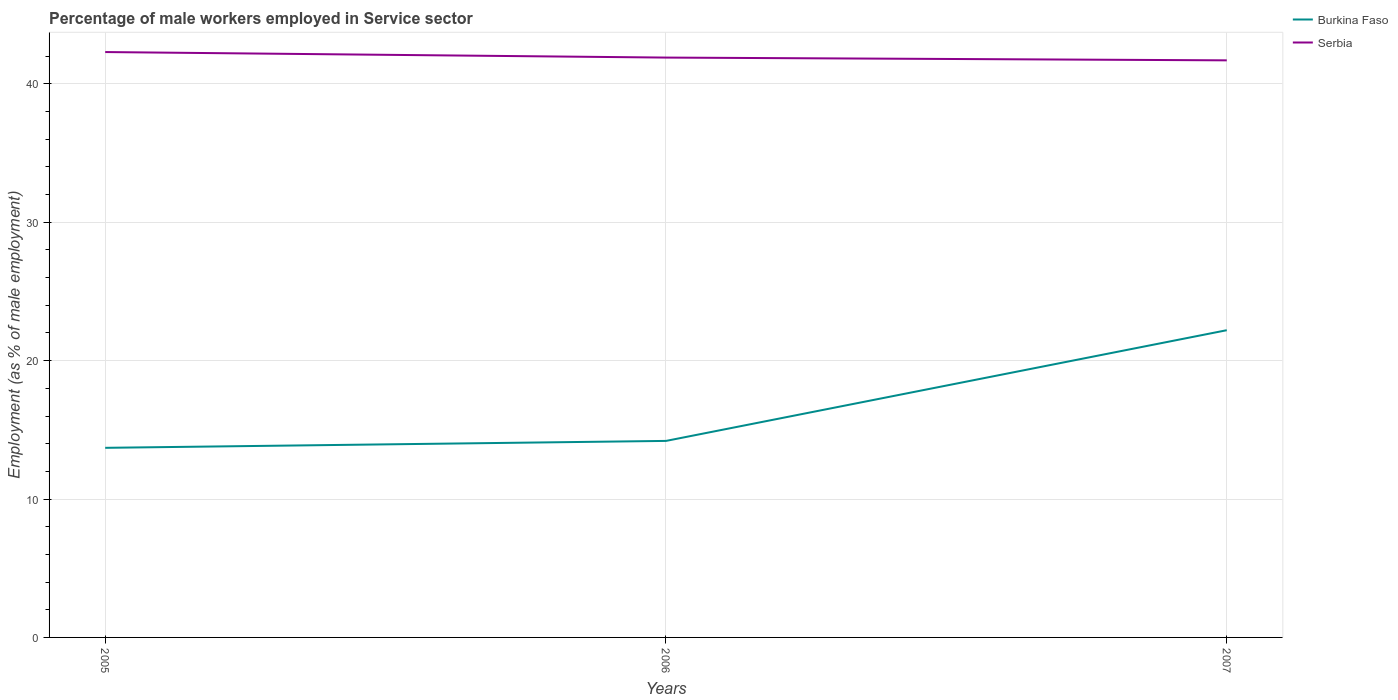Does the line corresponding to Serbia intersect with the line corresponding to Burkina Faso?
Your response must be concise. No. Across all years, what is the maximum percentage of male workers employed in Service sector in Serbia?
Provide a short and direct response. 41.7. What is the total percentage of male workers employed in Service sector in Serbia in the graph?
Keep it short and to the point. 0.4. What is the difference between the highest and the second highest percentage of male workers employed in Service sector in Serbia?
Provide a succinct answer. 0.6. What is the difference between the highest and the lowest percentage of male workers employed in Service sector in Serbia?
Give a very brief answer. 1. Is the percentage of male workers employed in Service sector in Serbia strictly greater than the percentage of male workers employed in Service sector in Burkina Faso over the years?
Your response must be concise. No. What is the difference between two consecutive major ticks on the Y-axis?
Give a very brief answer. 10. Are the values on the major ticks of Y-axis written in scientific E-notation?
Give a very brief answer. No. Does the graph contain any zero values?
Provide a succinct answer. No. How many legend labels are there?
Give a very brief answer. 2. What is the title of the graph?
Make the answer very short. Percentage of male workers employed in Service sector. Does "Small states" appear as one of the legend labels in the graph?
Make the answer very short. No. What is the label or title of the X-axis?
Your response must be concise. Years. What is the label or title of the Y-axis?
Provide a succinct answer. Employment (as % of male employment). What is the Employment (as % of male employment) of Burkina Faso in 2005?
Keep it short and to the point. 13.7. What is the Employment (as % of male employment) of Serbia in 2005?
Ensure brevity in your answer.  42.3. What is the Employment (as % of male employment) in Burkina Faso in 2006?
Make the answer very short. 14.2. What is the Employment (as % of male employment) of Serbia in 2006?
Offer a very short reply. 41.9. What is the Employment (as % of male employment) in Burkina Faso in 2007?
Make the answer very short. 22.2. What is the Employment (as % of male employment) of Serbia in 2007?
Give a very brief answer. 41.7. Across all years, what is the maximum Employment (as % of male employment) of Burkina Faso?
Your response must be concise. 22.2. Across all years, what is the maximum Employment (as % of male employment) of Serbia?
Your answer should be very brief. 42.3. Across all years, what is the minimum Employment (as % of male employment) of Burkina Faso?
Your response must be concise. 13.7. Across all years, what is the minimum Employment (as % of male employment) of Serbia?
Offer a very short reply. 41.7. What is the total Employment (as % of male employment) of Burkina Faso in the graph?
Keep it short and to the point. 50.1. What is the total Employment (as % of male employment) in Serbia in the graph?
Ensure brevity in your answer.  125.9. What is the difference between the Employment (as % of male employment) of Serbia in 2005 and that in 2006?
Your answer should be compact. 0.4. What is the difference between the Employment (as % of male employment) of Burkina Faso in 2005 and that in 2007?
Ensure brevity in your answer.  -8.5. What is the difference between the Employment (as % of male employment) of Burkina Faso in 2006 and that in 2007?
Offer a terse response. -8. What is the difference between the Employment (as % of male employment) in Burkina Faso in 2005 and the Employment (as % of male employment) in Serbia in 2006?
Make the answer very short. -28.2. What is the difference between the Employment (as % of male employment) in Burkina Faso in 2005 and the Employment (as % of male employment) in Serbia in 2007?
Provide a succinct answer. -28. What is the difference between the Employment (as % of male employment) in Burkina Faso in 2006 and the Employment (as % of male employment) in Serbia in 2007?
Your response must be concise. -27.5. What is the average Employment (as % of male employment) of Serbia per year?
Keep it short and to the point. 41.97. In the year 2005, what is the difference between the Employment (as % of male employment) of Burkina Faso and Employment (as % of male employment) of Serbia?
Ensure brevity in your answer.  -28.6. In the year 2006, what is the difference between the Employment (as % of male employment) of Burkina Faso and Employment (as % of male employment) of Serbia?
Ensure brevity in your answer.  -27.7. In the year 2007, what is the difference between the Employment (as % of male employment) in Burkina Faso and Employment (as % of male employment) in Serbia?
Keep it short and to the point. -19.5. What is the ratio of the Employment (as % of male employment) in Burkina Faso in 2005 to that in 2006?
Your answer should be compact. 0.96. What is the ratio of the Employment (as % of male employment) in Serbia in 2005 to that in 2006?
Your answer should be compact. 1.01. What is the ratio of the Employment (as % of male employment) in Burkina Faso in 2005 to that in 2007?
Provide a short and direct response. 0.62. What is the ratio of the Employment (as % of male employment) in Serbia in 2005 to that in 2007?
Make the answer very short. 1.01. What is the ratio of the Employment (as % of male employment) in Burkina Faso in 2006 to that in 2007?
Give a very brief answer. 0.64. What is the difference between the highest and the second highest Employment (as % of male employment) of Serbia?
Make the answer very short. 0.4. What is the difference between the highest and the lowest Employment (as % of male employment) in Serbia?
Your answer should be compact. 0.6. 